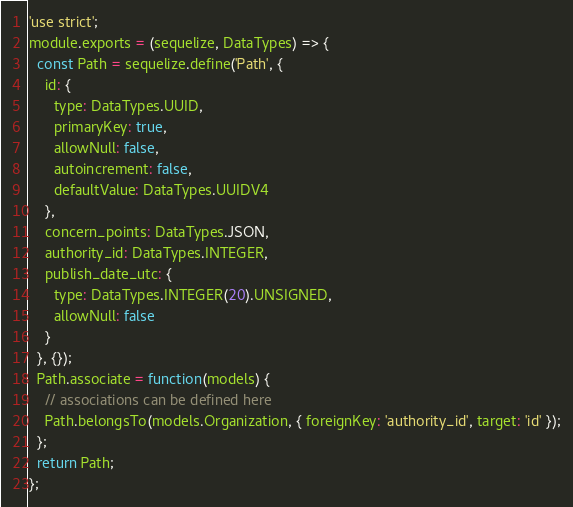<code> <loc_0><loc_0><loc_500><loc_500><_JavaScript_>'use strict';
module.exports = (sequelize, DataTypes) => {
  const Path = sequelize.define('Path', {
    id: {
      type: DataTypes.UUID,
      primaryKey: true,
      allowNull: false,
      autoincrement: false,
      defaultValue: DataTypes.UUIDV4
    },
    concern_points: DataTypes.JSON,
    authority_id: DataTypes.INTEGER,
    publish_date_utc: {
      type: DataTypes.INTEGER(20).UNSIGNED,
      allowNull: false
    }
  }, {});
  Path.associate = function(models) {
    // associations can be defined here
    Path.belongsTo(models.Organization, { foreignKey: 'authority_id', target: 'id' });
  };
  return Path;
};</code> 